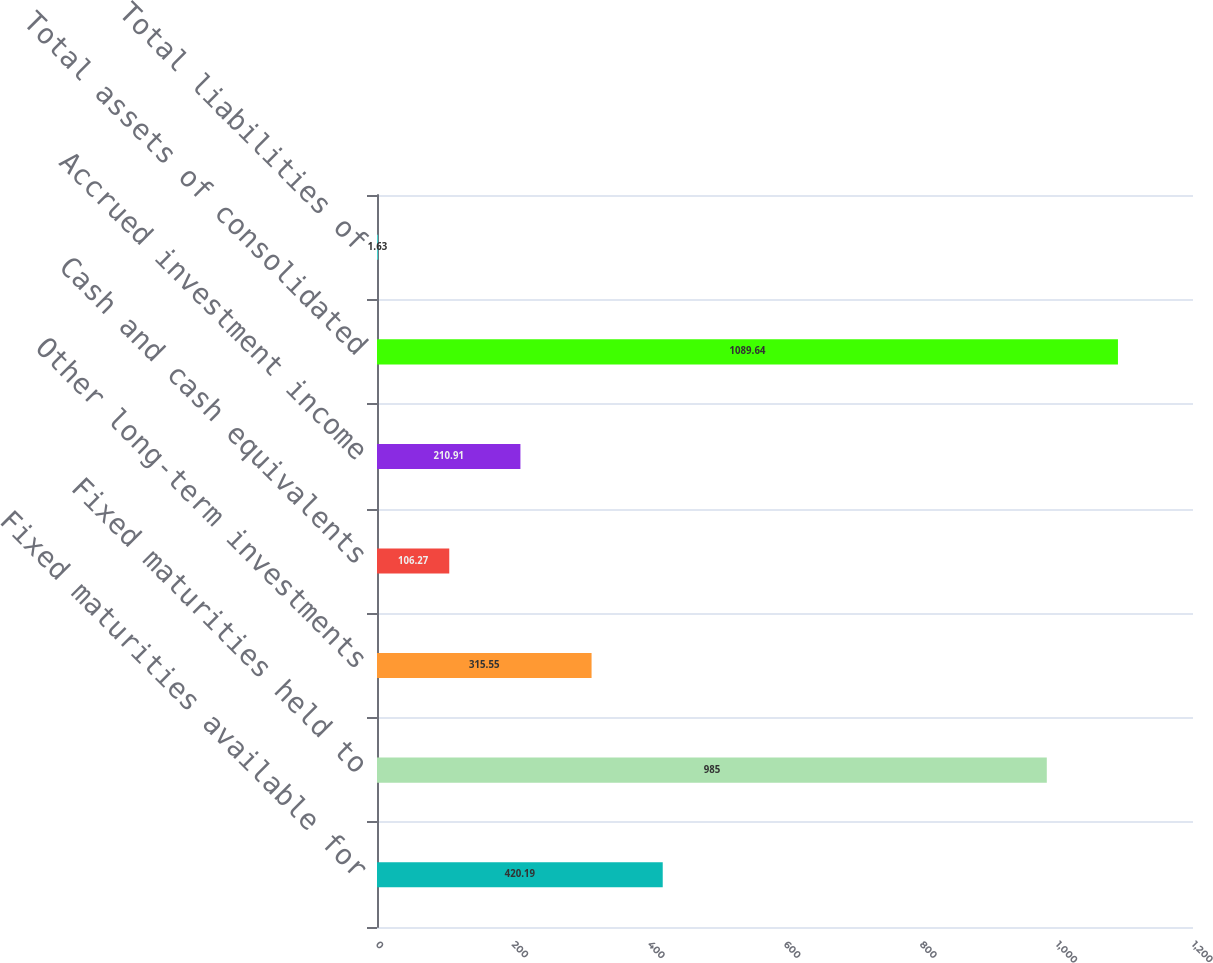<chart> <loc_0><loc_0><loc_500><loc_500><bar_chart><fcel>Fixed maturities available for<fcel>Fixed maturities held to<fcel>Other long-term investments<fcel>Cash and cash equivalents<fcel>Accrued investment income<fcel>Total assets of consolidated<fcel>Total liabilities of<nl><fcel>420.19<fcel>985<fcel>315.55<fcel>106.27<fcel>210.91<fcel>1089.64<fcel>1.63<nl></chart> 